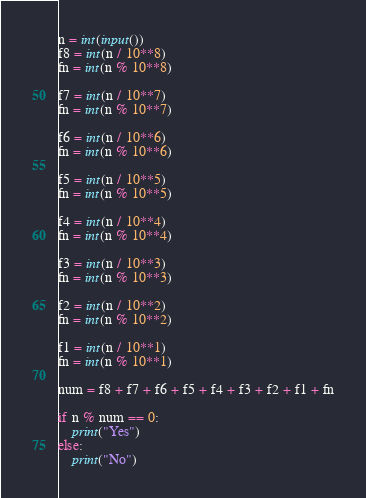<code> <loc_0><loc_0><loc_500><loc_500><_Python_>n = int(input())
f8 = int(n / 10**8)
fn = int(n % 10**8)

f7 = int(n / 10**7)
fn = int(n % 10**7)

f6 = int(n / 10**6)
fn = int(n % 10**6)

f5 = int(n / 10**5)
fn = int(n % 10**5)

f4 = int(n / 10**4)
fn = int(n % 10**4)

f3 = int(n / 10**3)
fn = int(n % 10**3)

f2 = int(n / 10**2)
fn = int(n % 10**2)

f1 = int(n / 10**1)
fn = int(n % 10**1)

num = f8 + f7 + f6 + f5 + f4 + f3 + f2 + f1 + fn

if n % num == 0:
    print("Yes")
else:
    print("No")</code> 